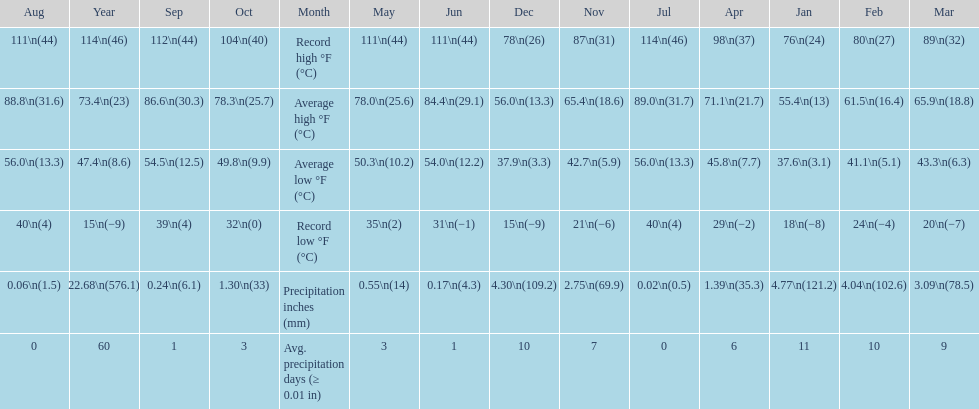Which month had an average high of 89.0 degrees and an average low of 56.0 degrees? July. 